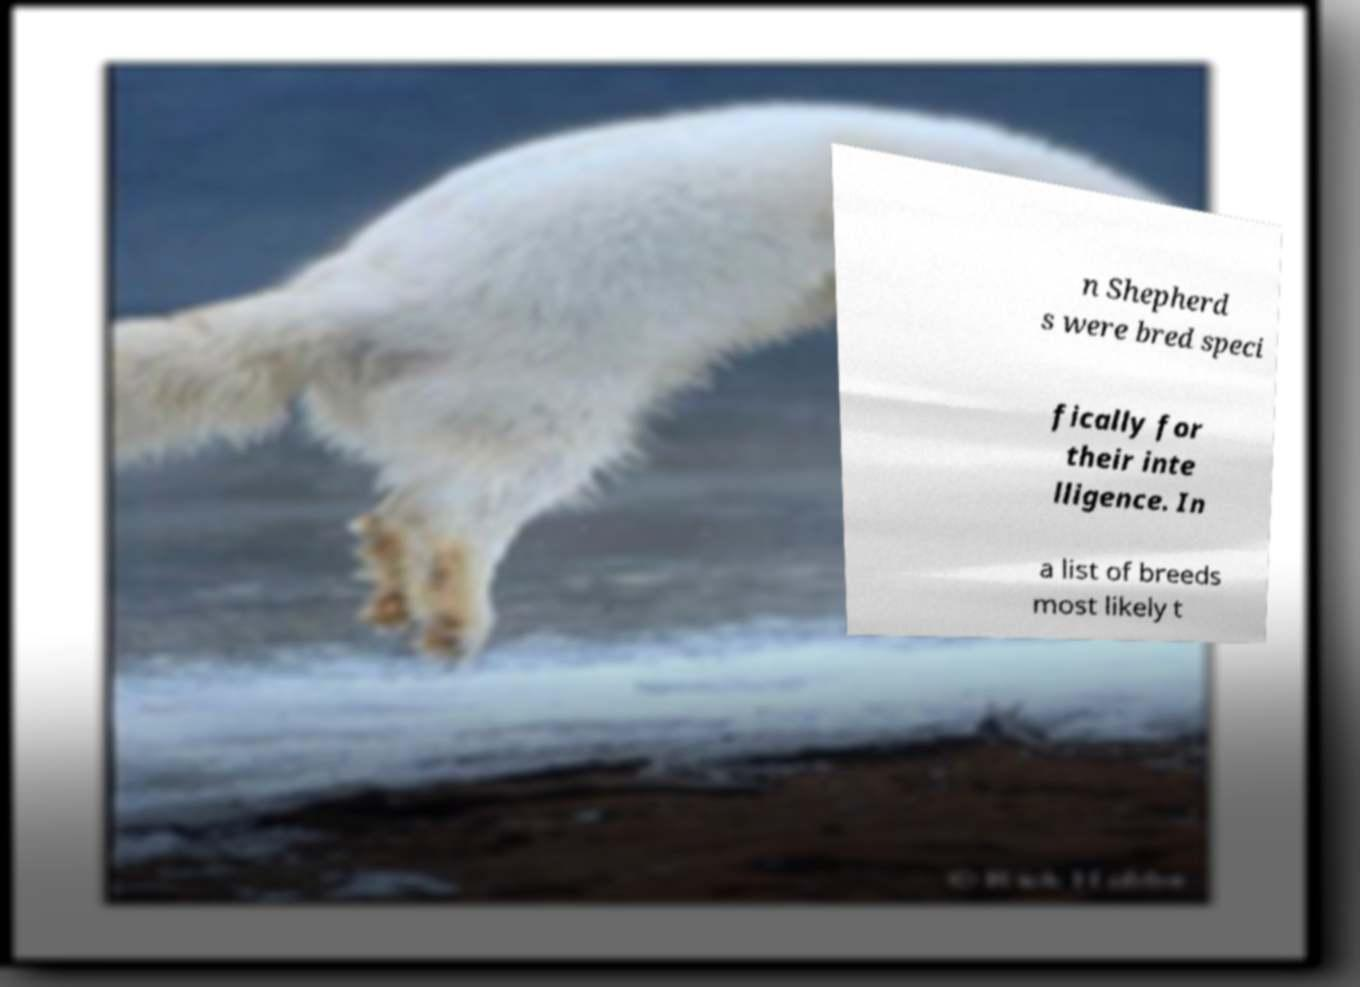There's text embedded in this image that I need extracted. Can you transcribe it verbatim? n Shepherd s were bred speci fically for their inte lligence. In a list of breeds most likely t 